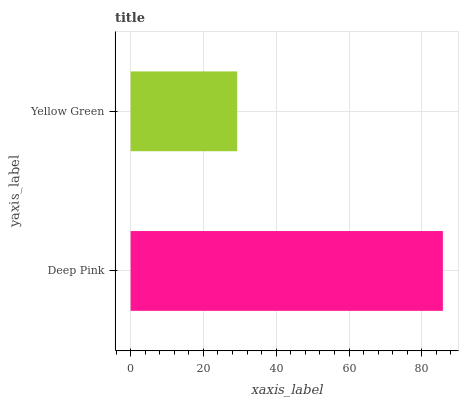Is Yellow Green the minimum?
Answer yes or no. Yes. Is Deep Pink the maximum?
Answer yes or no. Yes. Is Yellow Green the maximum?
Answer yes or no. No. Is Deep Pink greater than Yellow Green?
Answer yes or no. Yes. Is Yellow Green less than Deep Pink?
Answer yes or no. Yes. Is Yellow Green greater than Deep Pink?
Answer yes or no. No. Is Deep Pink less than Yellow Green?
Answer yes or no. No. Is Deep Pink the high median?
Answer yes or no. Yes. Is Yellow Green the low median?
Answer yes or no. Yes. Is Yellow Green the high median?
Answer yes or no. No. Is Deep Pink the low median?
Answer yes or no. No. 